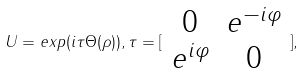<formula> <loc_0><loc_0><loc_500><loc_500>U = e x p ( i \tau \Theta ( \rho ) ) , \tau = [ \begin{array} { c c } 0 & e ^ { - i \varphi } \\ e ^ { i \varphi } & 0 \end{array} ] ,</formula> 